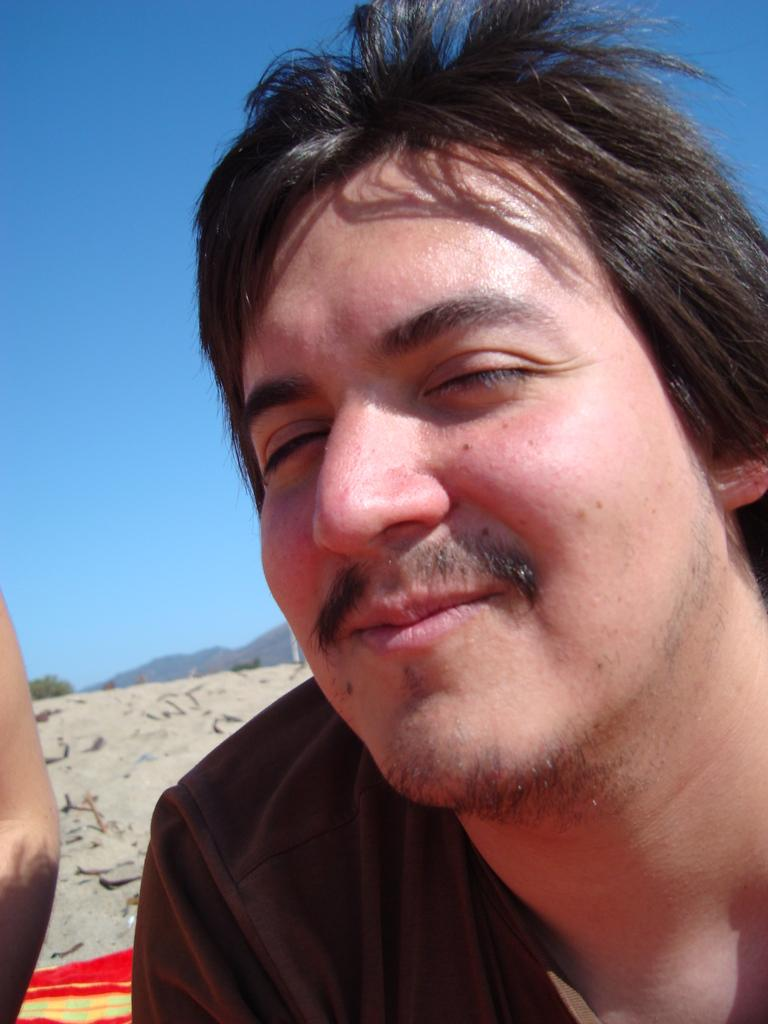What is the main subject of the image? There is a person in the image. What is the person wearing? The person is wearing a t-shirt. What is the person's facial expression? The person is smiling. What type of surface can be seen in the background of the image? There is a sand surface in the background of the image. What natural elements are visible in the background of the image? There is a tree, a mountain, and the sky in the background of the image. What color is the sky in the background of the image? The sky is blue in the background of the image. How many oranges are being held by the person in the image? There are no oranges present in the image. What type of approval is the person seeking in the image? The image does not depict the person seeking any type of approval. 